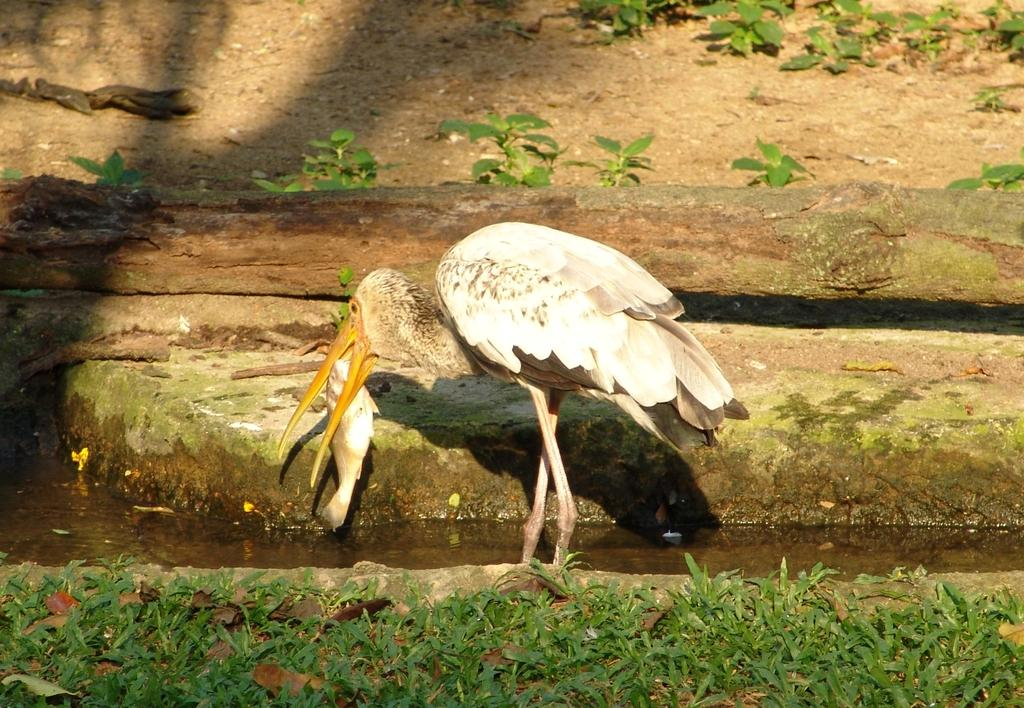What is the main subject of the image? There is a crane in the image. What is the crane doing in the image? The crane is holding a fish in its mouth. What can be seen in the background of the image? There are planets, a log, water, and ground visible in the background of the image. How many cakes are being offered to the sheep in the image? There are no cakes or sheep present in the image. 